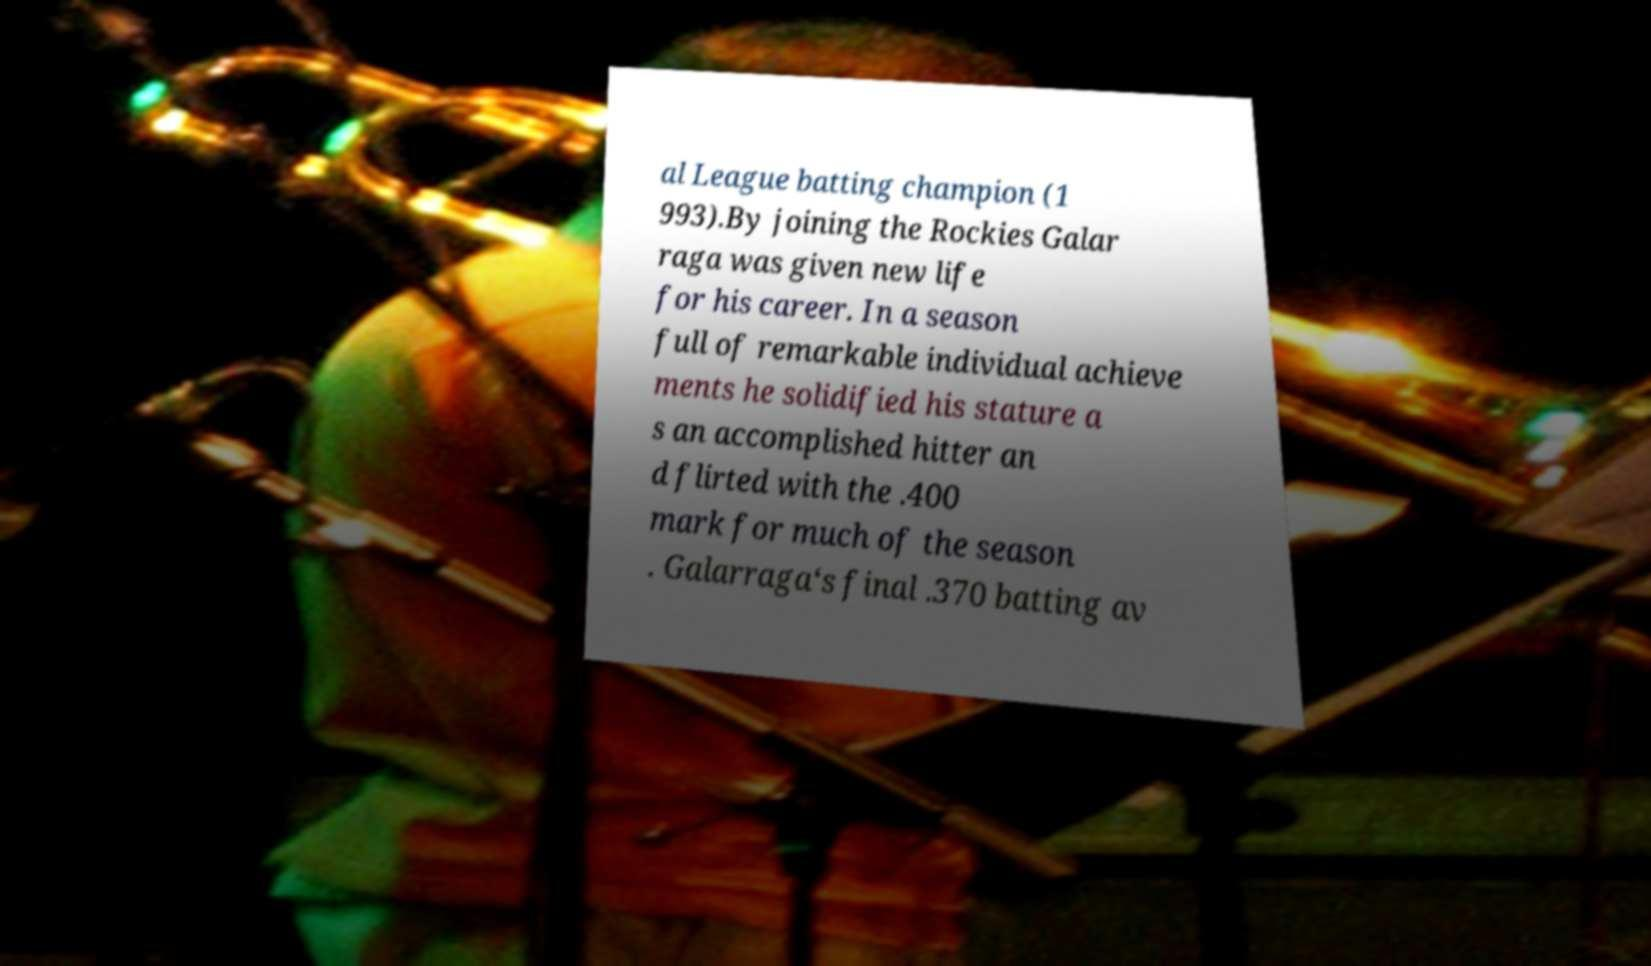Please identify and transcribe the text found in this image. al League batting champion (1 993).By joining the Rockies Galar raga was given new life for his career. In a season full of remarkable individual achieve ments he solidified his stature a s an accomplished hitter an d flirted with the .400 mark for much of the season . Galarraga‘s final .370 batting av 